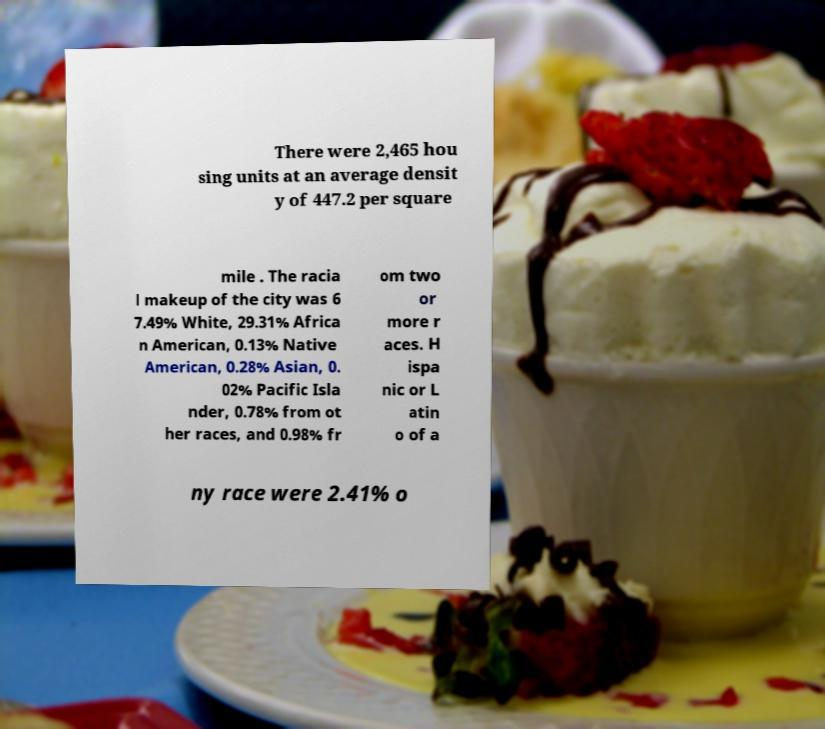For documentation purposes, I need the text within this image transcribed. Could you provide that? There were 2,465 hou sing units at an average densit y of 447.2 per square mile . The racia l makeup of the city was 6 7.49% White, 29.31% Africa n American, 0.13% Native American, 0.28% Asian, 0. 02% Pacific Isla nder, 0.78% from ot her races, and 0.98% fr om two or more r aces. H ispa nic or L atin o of a ny race were 2.41% o 